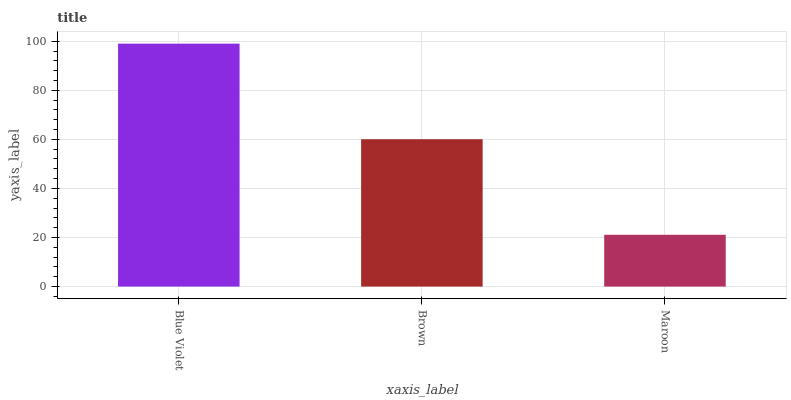Is Maroon the minimum?
Answer yes or no. Yes. Is Blue Violet the maximum?
Answer yes or no. Yes. Is Brown the minimum?
Answer yes or no. No. Is Brown the maximum?
Answer yes or no. No. Is Blue Violet greater than Brown?
Answer yes or no. Yes. Is Brown less than Blue Violet?
Answer yes or no. Yes. Is Brown greater than Blue Violet?
Answer yes or no. No. Is Blue Violet less than Brown?
Answer yes or no. No. Is Brown the high median?
Answer yes or no. Yes. Is Brown the low median?
Answer yes or no. Yes. Is Maroon the high median?
Answer yes or no. No. Is Blue Violet the low median?
Answer yes or no. No. 